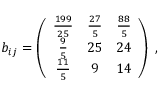<formula> <loc_0><loc_0><loc_500><loc_500>b _ { i j } = \left ( \begin{array} { c c c } { { { \frac { 1 9 9 } { 2 5 } } } } & { { { \frac { 2 7 } { 5 } } } } & { { { \frac { 8 8 } { 5 } } } } \\ { { { \frac { 9 } { 5 } } } } & { 2 5 } & { 2 4 } \\ { { { \frac { 1 1 } { 5 } } } } & { 9 } & { 1 4 } \end{array} \right ) \, ,</formula> 